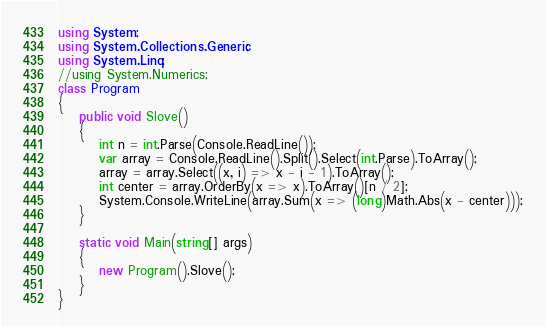<code> <loc_0><loc_0><loc_500><loc_500><_C#_>using System;
using System.Collections.Generic;
using System.Linq;
//using System.Numerics;
class Program
{       
    public void Slove()
    {
        int n = int.Parse(Console.ReadLine());
        var array = Console.ReadLine().Split().Select(int.Parse).ToArray();
        array = array.Select((x, i) => x - i - 1).ToArray();
        int center = array.OrderBy(x => x).ToArray()[n / 2];
        System.Console.WriteLine(array.Sum(x => (long)Math.Abs(x - center)));
    }
    
    static void Main(string[] args)
    {
        new Program().Slove();
    }
}
</code> 